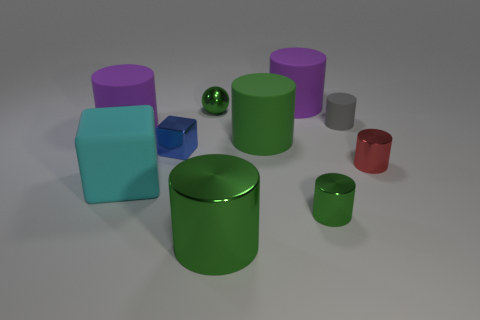There is a purple cylinder that is behind the purple rubber cylinder that is to the left of the large green matte thing; what is it made of?
Your response must be concise. Rubber. The small rubber cylinder has what color?
Your response must be concise. Gray. Do the thing behind the tiny metal sphere and the big matte object that is in front of the small red shiny cylinder have the same color?
Keep it short and to the point. No. There is a green rubber thing that is the same shape as the small gray object; what is its size?
Provide a short and direct response. Large. Is there another tiny metal ball of the same color as the small ball?
Your answer should be compact. No. There is a tiny ball that is the same color as the big shiny thing; what material is it?
Give a very brief answer. Metal. How many tiny balls have the same color as the metal cube?
Offer a terse response. 0. How many objects are either small green objects that are behind the tiny rubber object or metallic balls?
Keep it short and to the point. 1. There is a tiny cylinder that is made of the same material as the big cyan block; what color is it?
Your answer should be very brief. Gray. Is there a brown metallic object that has the same size as the cyan matte cube?
Your response must be concise. No. 